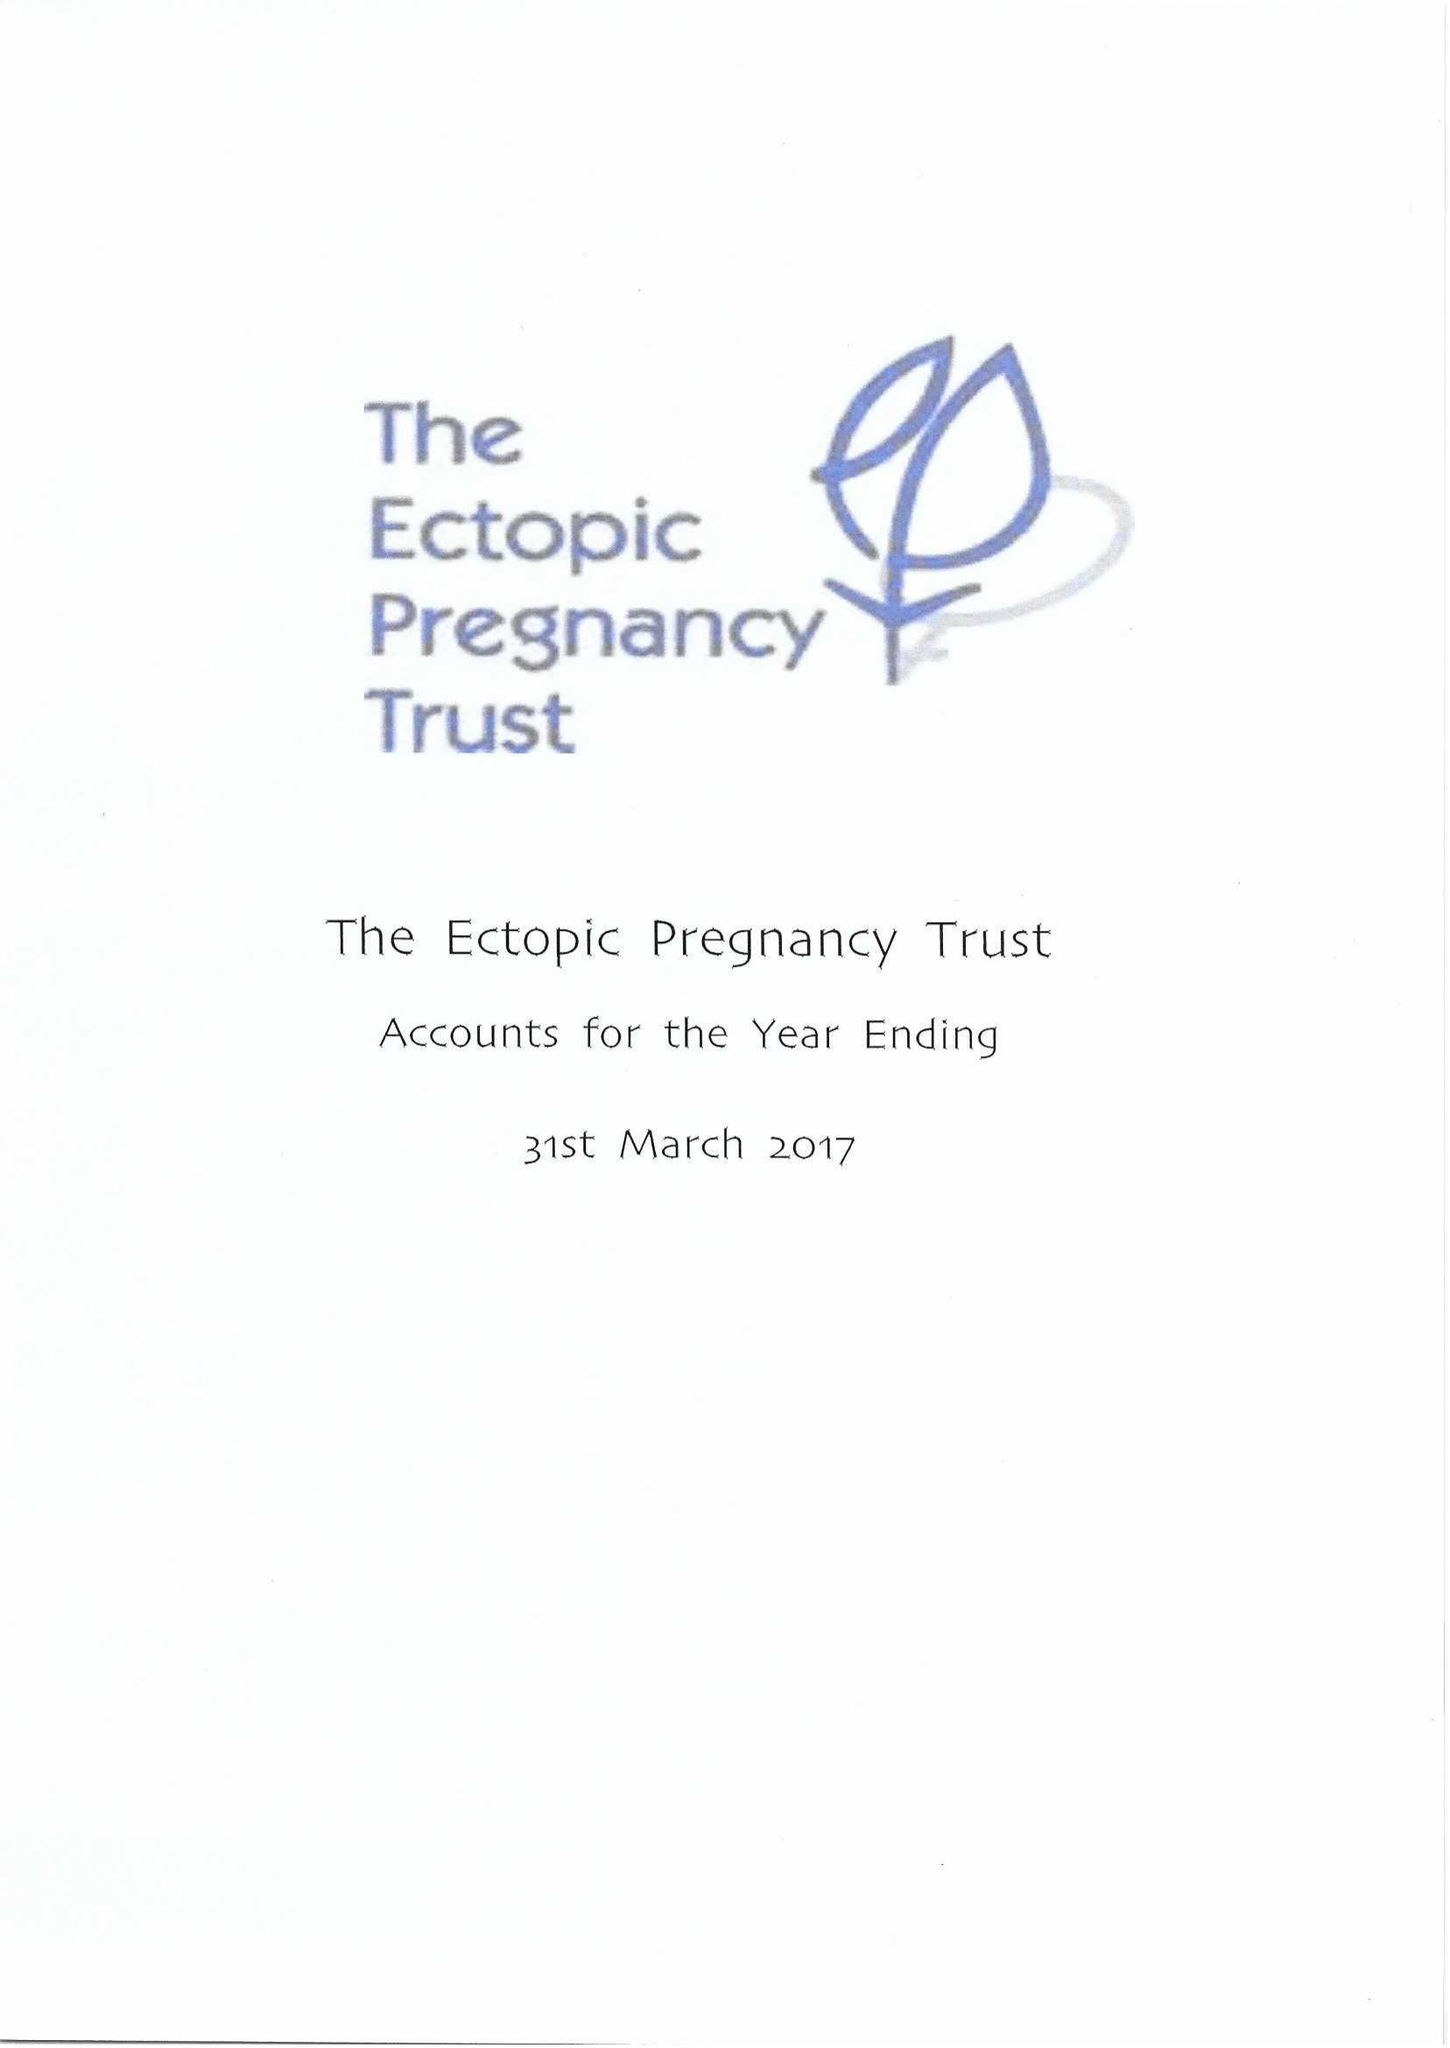What is the value for the spending_annually_in_british_pounds?
Answer the question using a single word or phrase. 58034.00 